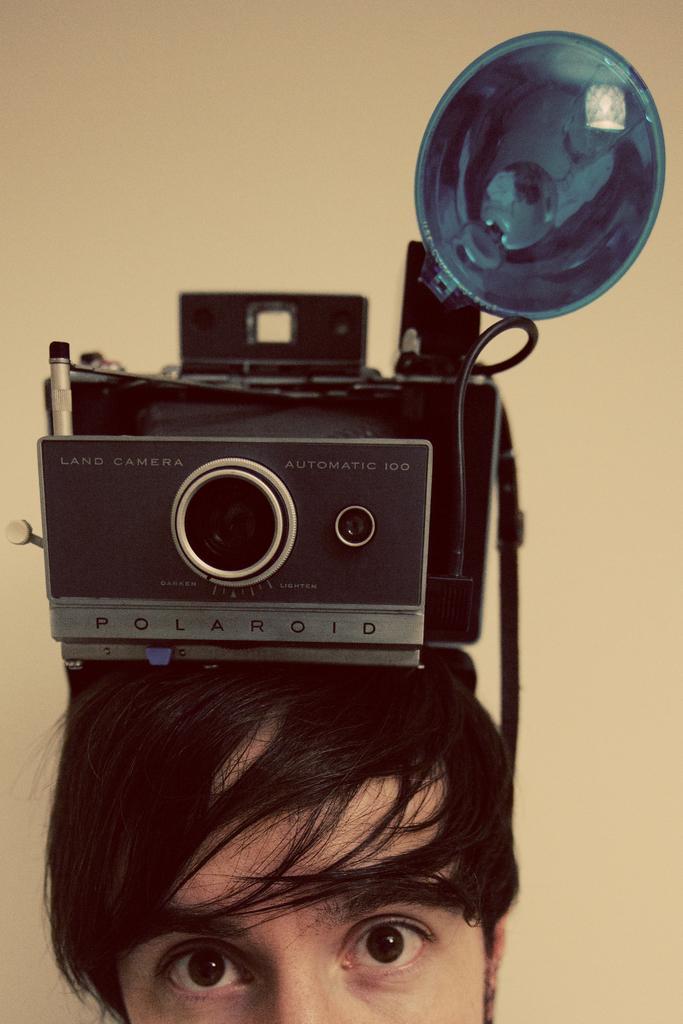Please provide a concise description of this image. In this image there is one camera is on a person's head as we can see in the bottom of this image. There is a wall in the background. 